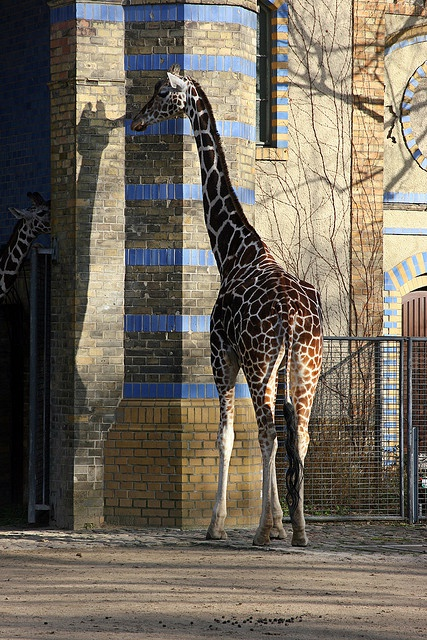Describe the objects in this image and their specific colors. I can see giraffe in black, gray, ivory, and maroon tones and giraffe in black and gray tones in this image. 